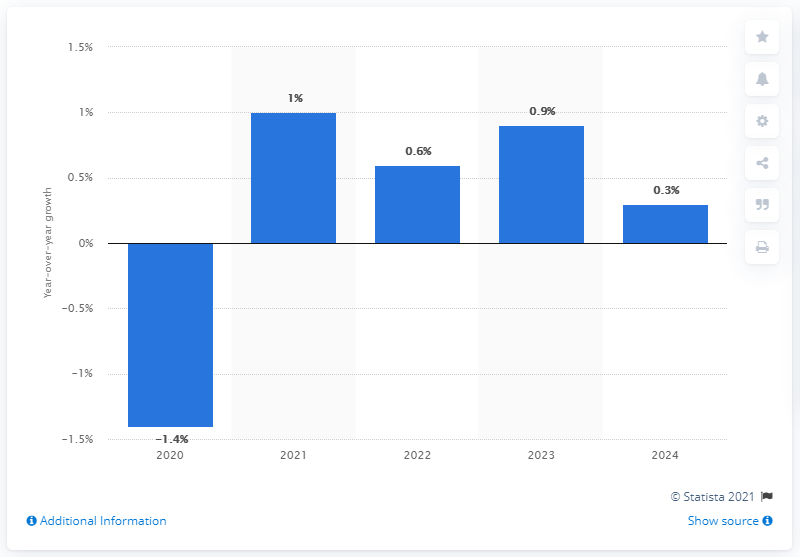Draw attention to some important aspects in this diagram. The forecasted growth in worldwide spending in the telecom services industry is expected to occur in 2024. The telecom services market is projected to increase again in 2021. 